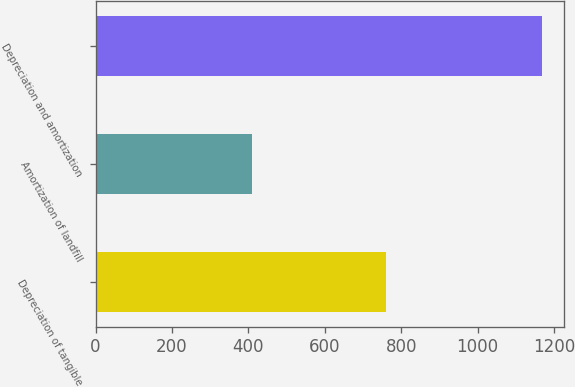Convert chart to OTSL. <chart><loc_0><loc_0><loc_500><loc_500><bar_chart><fcel>Depreciation of tangible<fcel>Amortization of landfill<fcel>Depreciation and amortization<nl><fcel>760<fcel>409<fcel>1169<nl></chart> 